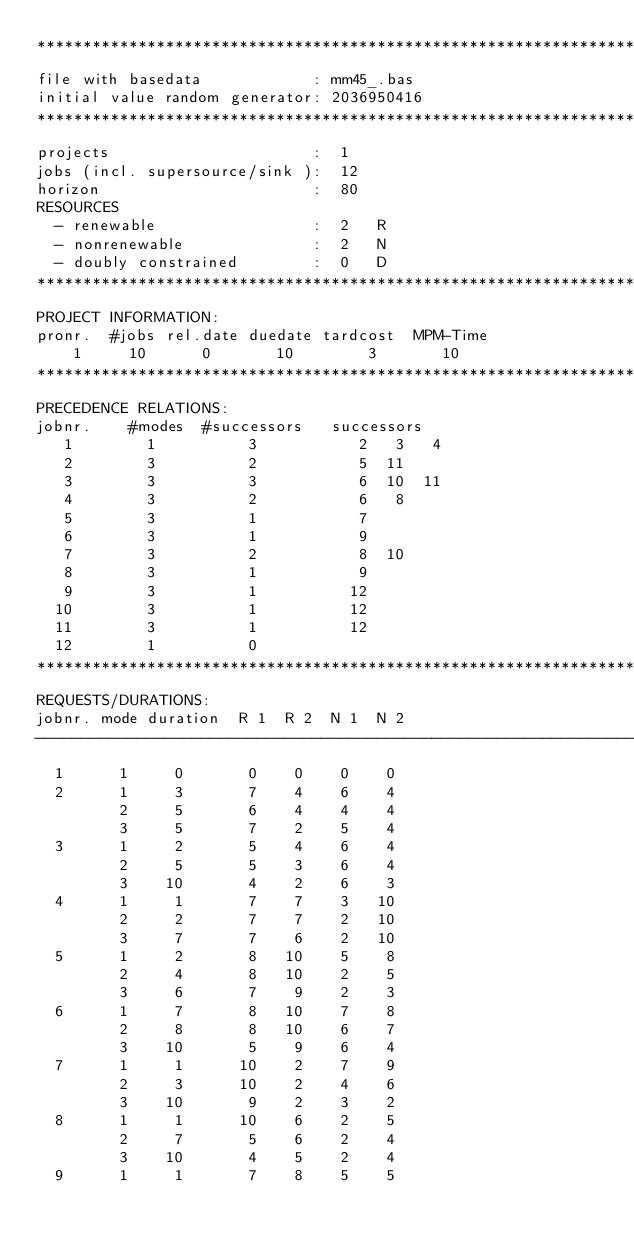<code> <loc_0><loc_0><loc_500><loc_500><_ObjectiveC_>************************************************************************
file with basedata            : mm45_.bas
initial value random generator: 2036950416
************************************************************************
projects                      :  1
jobs (incl. supersource/sink ):  12
horizon                       :  80
RESOURCES
  - renewable                 :  2   R
  - nonrenewable              :  2   N
  - doubly constrained        :  0   D
************************************************************************
PROJECT INFORMATION:
pronr.  #jobs rel.date duedate tardcost  MPM-Time
    1     10      0       10        3       10
************************************************************************
PRECEDENCE RELATIONS:
jobnr.    #modes  #successors   successors
   1        1          3           2   3   4
   2        3          2           5  11
   3        3          3           6  10  11
   4        3          2           6   8
   5        3          1           7
   6        3          1           9
   7        3          2           8  10
   8        3          1           9
   9        3          1          12
  10        3          1          12
  11        3          1          12
  12        1          0        
************************************************************************
REQUESTS/DURATIONS:
jobnr. mode duration  R 1  R 2  N 1  N 2
------------------------------------------------------------------------
  1      1     0       0    0    0    0
  2      1     3       7    4    6    4
         2     5       6    4    4    4
         3     5       7    2    5    4
  3      1     2       5    4    6    4
         2     5       5    3    6    4
         3    10       4    2    6    3
  4      1     1       7    7    3   10
         2     2       7    7    2   10
         3     7       7    6    2   10
  5      1     2       8   10    5    8
         2     4       8   10    2    5
         3     6       7    9    2    3
  6      1     7       8   10    7    8
         2     8       8   10    6    7
         3    10       5    9    6    4
  7      1     1      10    2    7    9
         2     3      10    2    4    6
         3    10       9    2    3    2
  8      1     1      10    6    2    5
         2     7       5    6    2    4
         3    10       4    5    2    4
  9      1     1       7    8    5    5</code> 